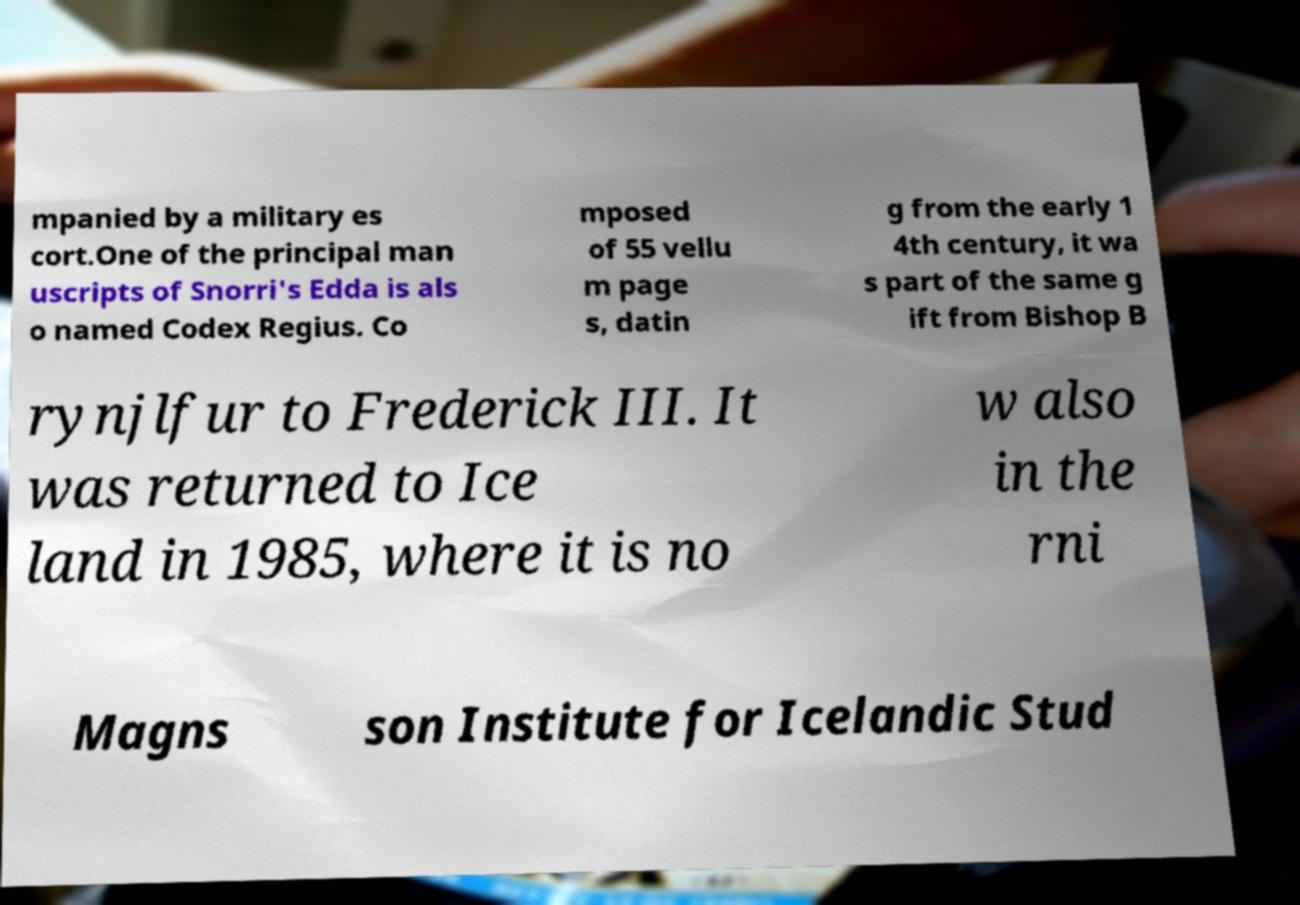What messages or text are displayed in this image? I need them in a readable, typed format. mpanied by a military es cort.One of the principal man uscripts of Snorri's Edda is als o named Codex Regius. Co mposed of 55 vellu m page s, datin g from the early 1 4th century, it wa s part of the same g ift from Bishop B rynjlfur to Frederick III. It was returned to Ice land in 1985, where it is no w also in the rni Magns son Institute for Icelandic Stud 